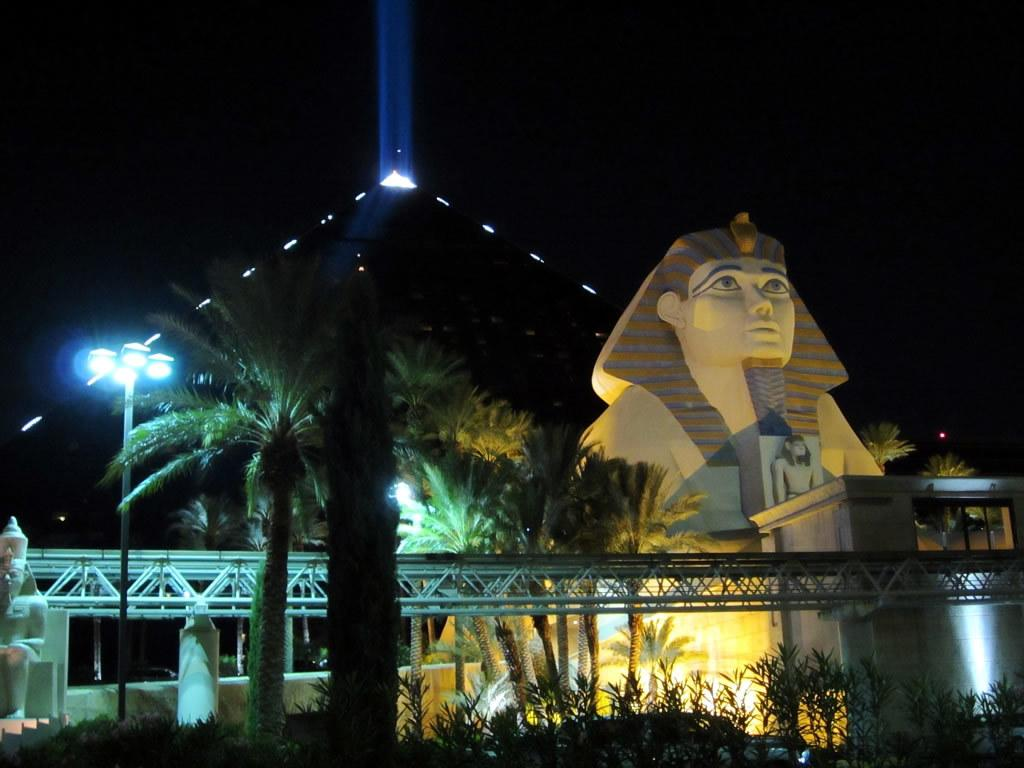What type of artwork is present in the image? There are sculptures in the image. What else can be seen in the image besides the sculptures? There are lights and trees visible in the image. How would you describe the lighting conditions in the image? The background of the image is dark. What type of bottle is being used by the doctor to express love in the image? There is no bottle, doctor, or expression of love present in the image. 